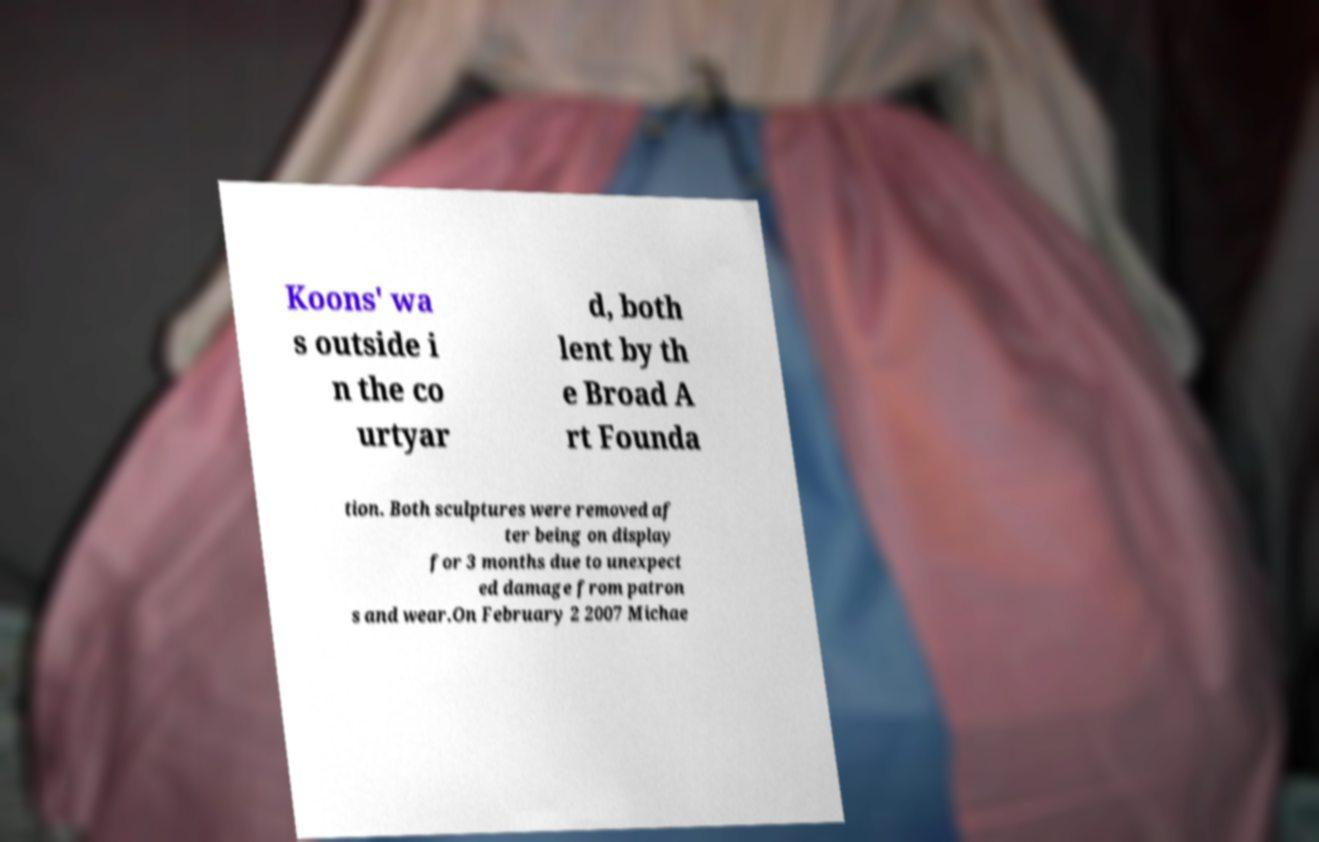Can you read and provide the text displayed in the image?This photo seems to have some interesting text. Can you extract and type it out for me? Koons' wa s outside i n the co urtyar d, both lent by th e Broad A rt Founda tion. Both sculptures were removed af ter being on display for 3 months due to unexpect ed damage from patron s and wear.On February 2 2007 Michae 